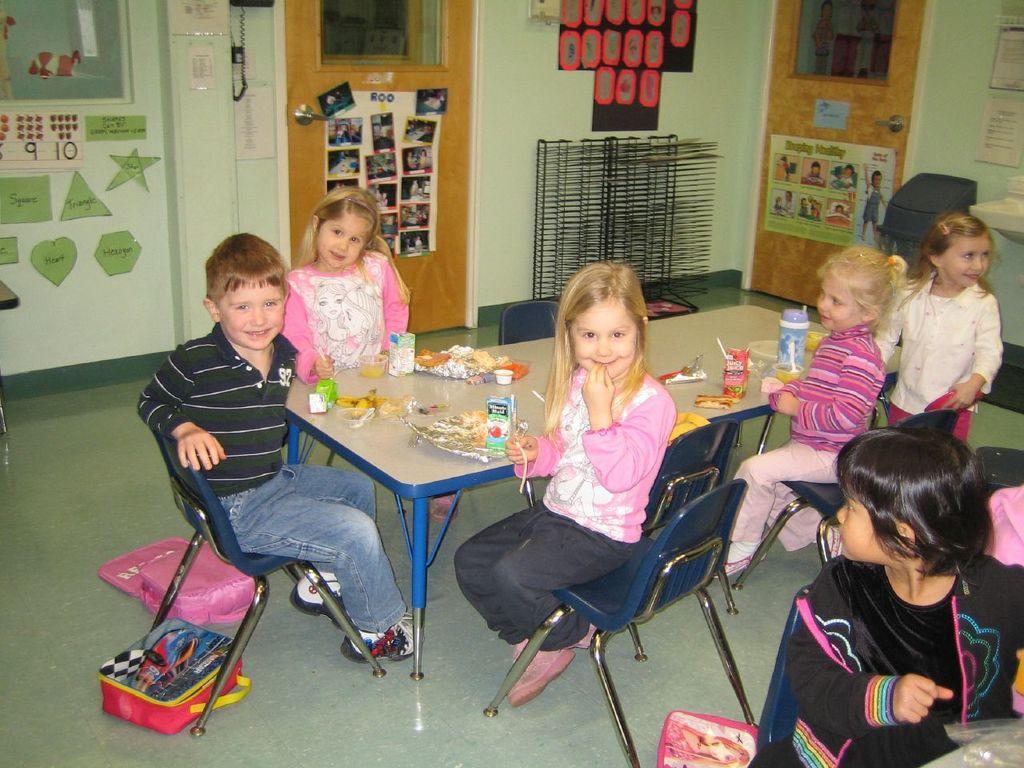Please provide a concise description of this image. In this image, there are six kids. Three of them are sitting in the middle of the image. Two of them sitting in middle right most of the image. One kid is sitting at the bottom of the image right. On the floor bags are kept. In the middle of the image there is a table, on which fruits, juice packs, bottle, food is kept. In the background, there is a door on which photos are attached, beside that telephone is there attached to the wall. In the right side of the image top, there is another door. In the right side middle of the image, there is a wash basin. On above that papers are stick to the wall. In the background the wall is green in color light green. 